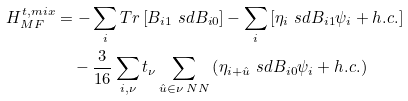<formula> <loc_0><loc_0><loc_500><loc_500>H _ { M F } ^ { t , m i x } & = - \sum _ { i } T r \left [ B _ { i 1 } \ s d B _ { i 0 } \right ] - \sum _ { i } \left [ \eta _ { i } \ s d B _ { i 1 } \psi _ { i } + h . c . \right ] \\ & \quad - \frac { 3 } { 1 6 } \sum _ { i , \nu } t _ { \nu } \sum _ { \hat { u } \in \nu \, N N } \left ( \eta _ { i + \hat { u } } \ s d B _ { i 0 } \psi _ { i } + h . c . \right )</formula> 